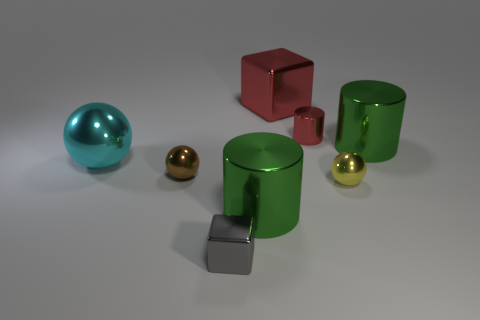Subtract all brown metal spheres. How many spheres are left? 2 Add 1 red metallic things. How many objects exist? 9 Subtract all spheres. How many objects are left? 5 Add 1 small yellow things. How many small yellow things are left? 2 Add 2 large brown rubber spheres. How many large brown rubber spheres exist? 2 Subtract 0 purple cylinders. How many objects are left? 8 Subtract all metal balls. Subtract all tiny cubes. How many objects are left? 4 